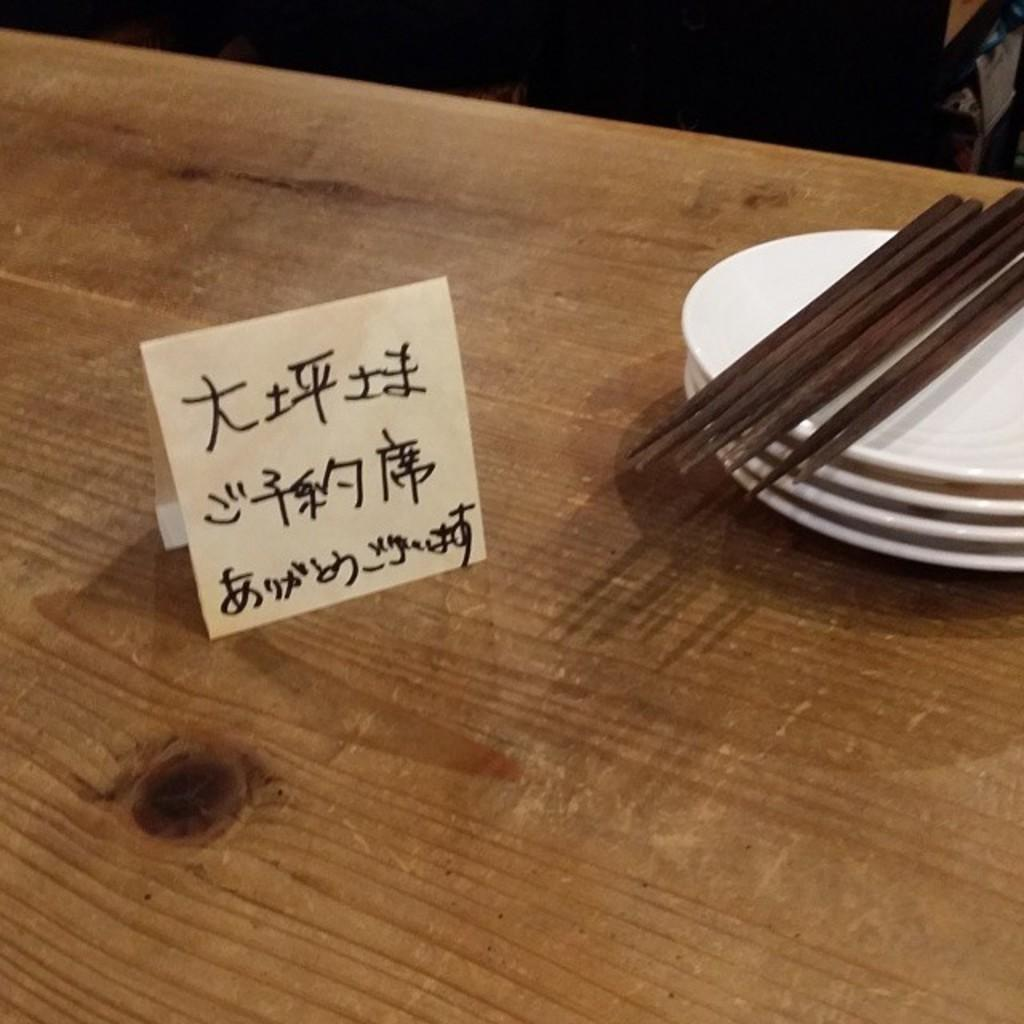What objects can be seen on the table in the image? There is a board on a table in the image. What else is visible on the table besides the board? There are plates and sticks visible on the table in the image. What is the color of the background in the image? The background of the image is dark. What type of mitten is being used for the activity in the image? There is no mitten or activity present in the image. What type of building can be seen in the background of the image? The background of the image is dark, and no building is visible. 